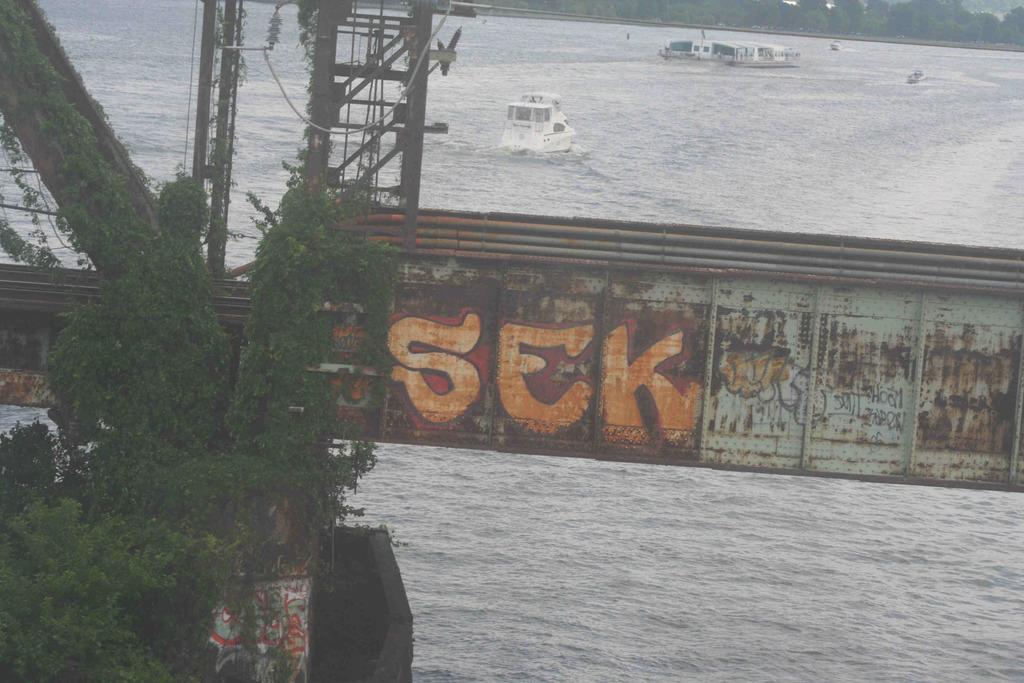What is the main structure in the center of the image? There is a bridge railing in the center of the image. What is located below the bridge railing? There is a river at the bottom of the image. What can be seen in the river? Ships are visible in the river. What type of natural scenery is visible in the background of the image? There are trees in the background of the image. What type of comfort can be found in the image? The image does not depict any objects or situations related to comfort. Is there any cork visible in the image? There is no cork present in the image. 